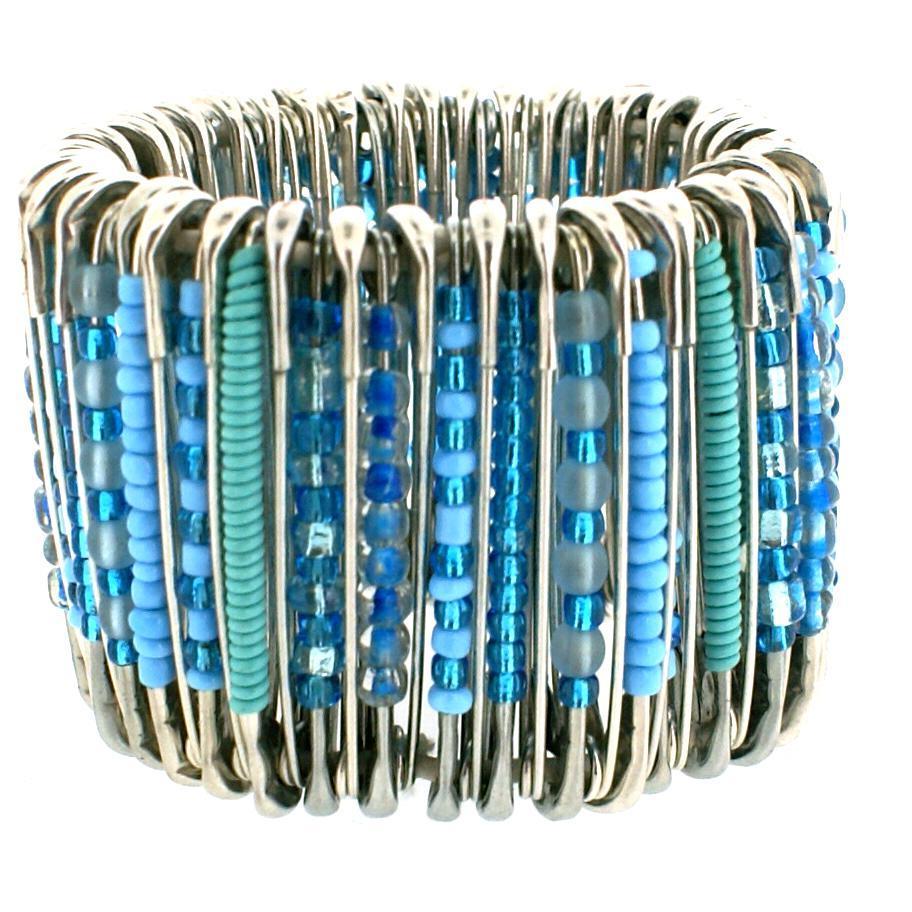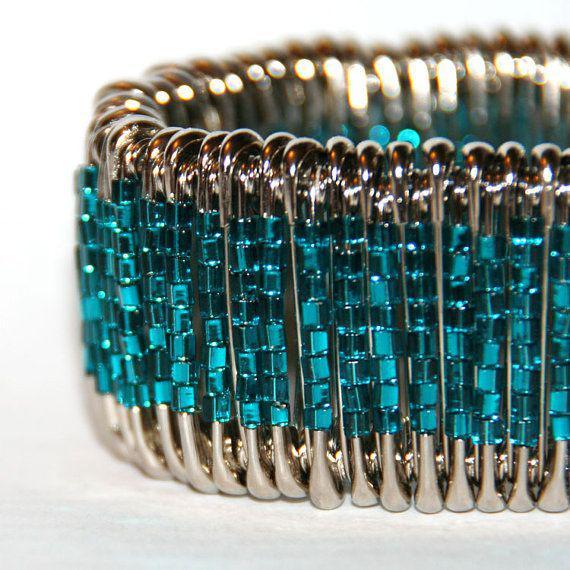The first image is the image on the left, the second image is the image on the right. Given the left and right images, does the statement "A bracelet is being modeled in the image on the left." hold true? Answer yes or no. No. The first image is the image on the left, the second image is the image on the right. Examine the images to the left and right. Is the description "The left image contains a persons wrist modeling a bracelet with many beads." accurate? Answer yes or no. No. 